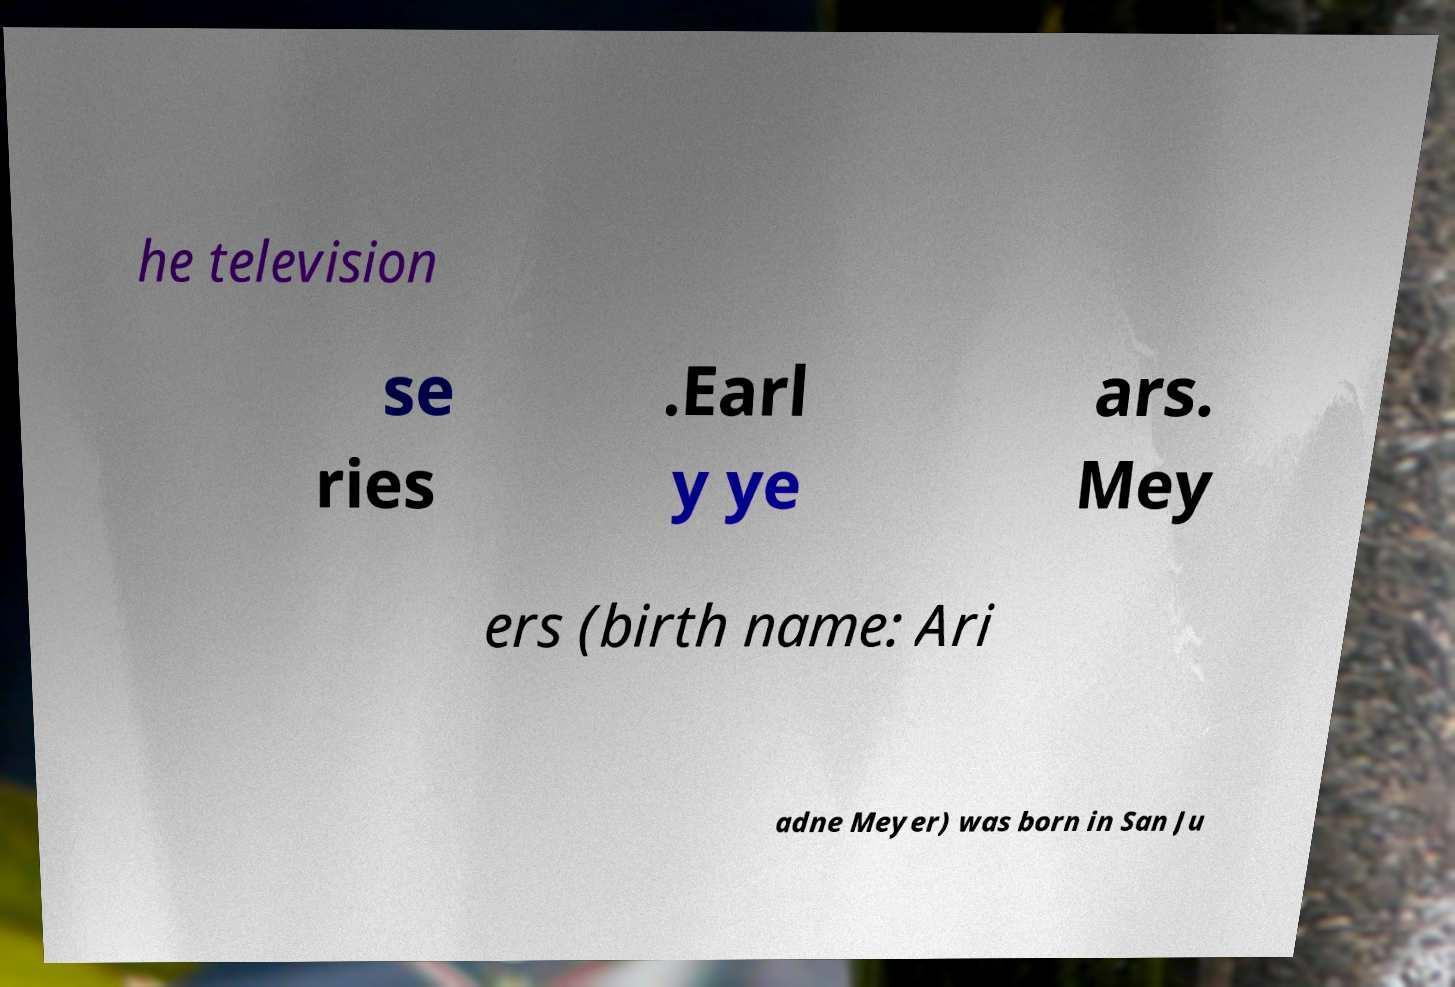Could you extract and type out the text from this image? he television se ries .Earl y ye ars. Mey ers (birth name: Ari adne Meyer) was born in San Ju 